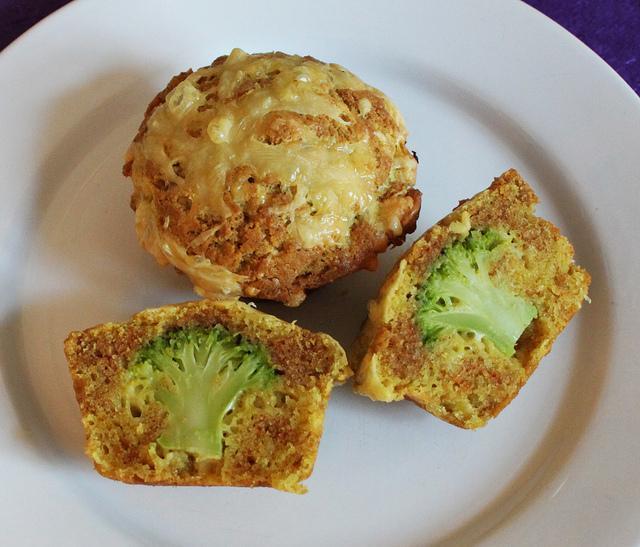How many pieces are there on the plate?
Give a very brief answer. 3. How many broccolis are there?
Give a very brief answer. 2. 